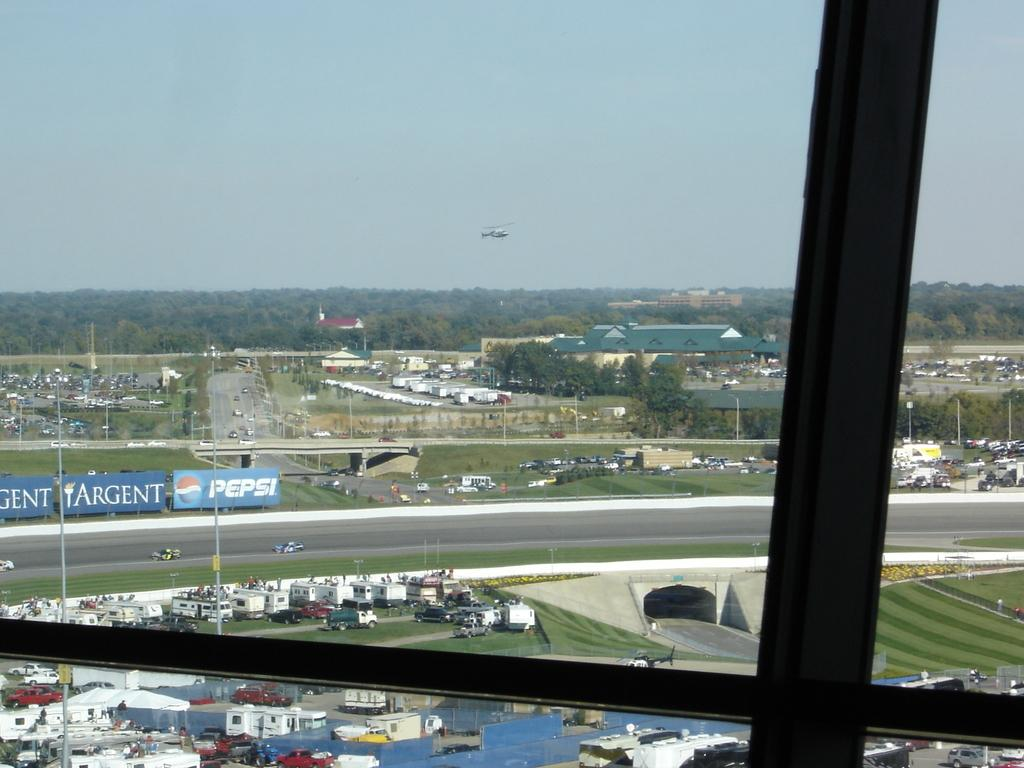<image>
Share a concise interpretation of the image provided. A Pepsi billboard is on the side of a racetrack. 